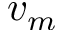<formula> <loc_0><loc_0><loc_500><loc_500>v _ { m }</formula> 